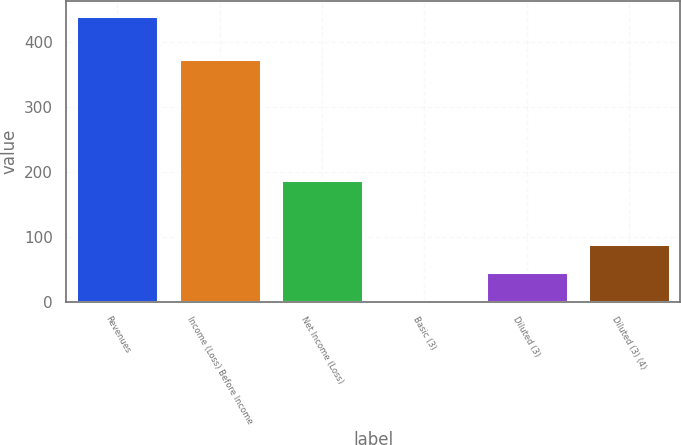Convert chart to OTSL. <chart><loc_0><loc_0><loc_500><loc_500><bar_chart><fcel>Revenues<fcel>Income (Loss) Before Income<fcel>Net Income (Loss)<fcel>Basic (3)<fcel>Diluted (3)<fcel>Diluted (3) (4)<nl><fcel>441<fcel>374<fcel>188<fcel>1.09<fcel>45.08<fcel>89.07<nl></chart> 